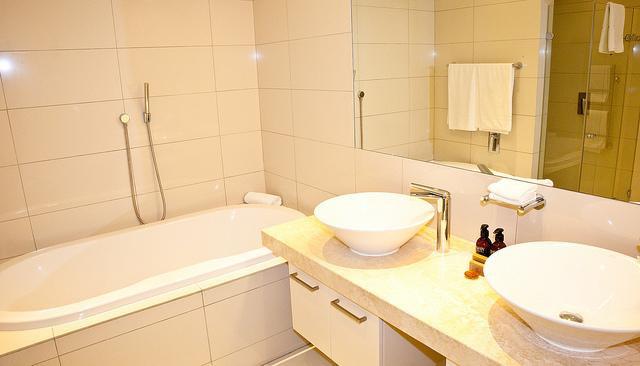What type of sinks are these? Please explain your reasoning. bowl sinks. This is obvious given their shape. 